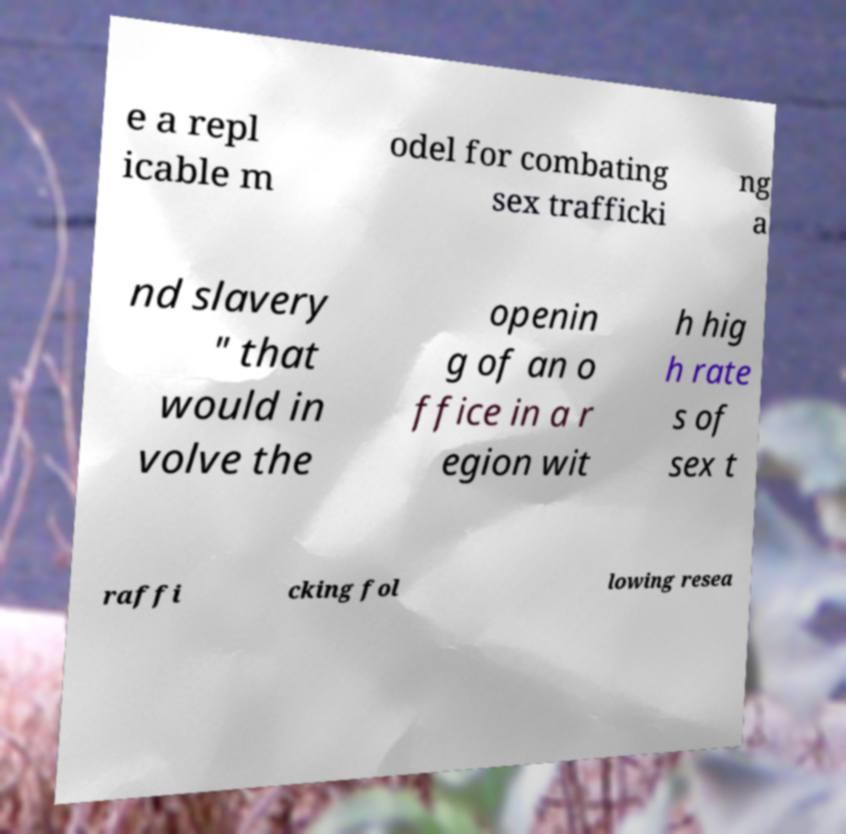There's text embedded in this image that I need extracted. Can you transcribe it verbatim? e a repl icable m odel for combating sex trafficki ng a nd slavery " that would in volve the openin g of an o ffice in a r egion wit h hig h rate s of sex t raffi cking fol lowing resea 